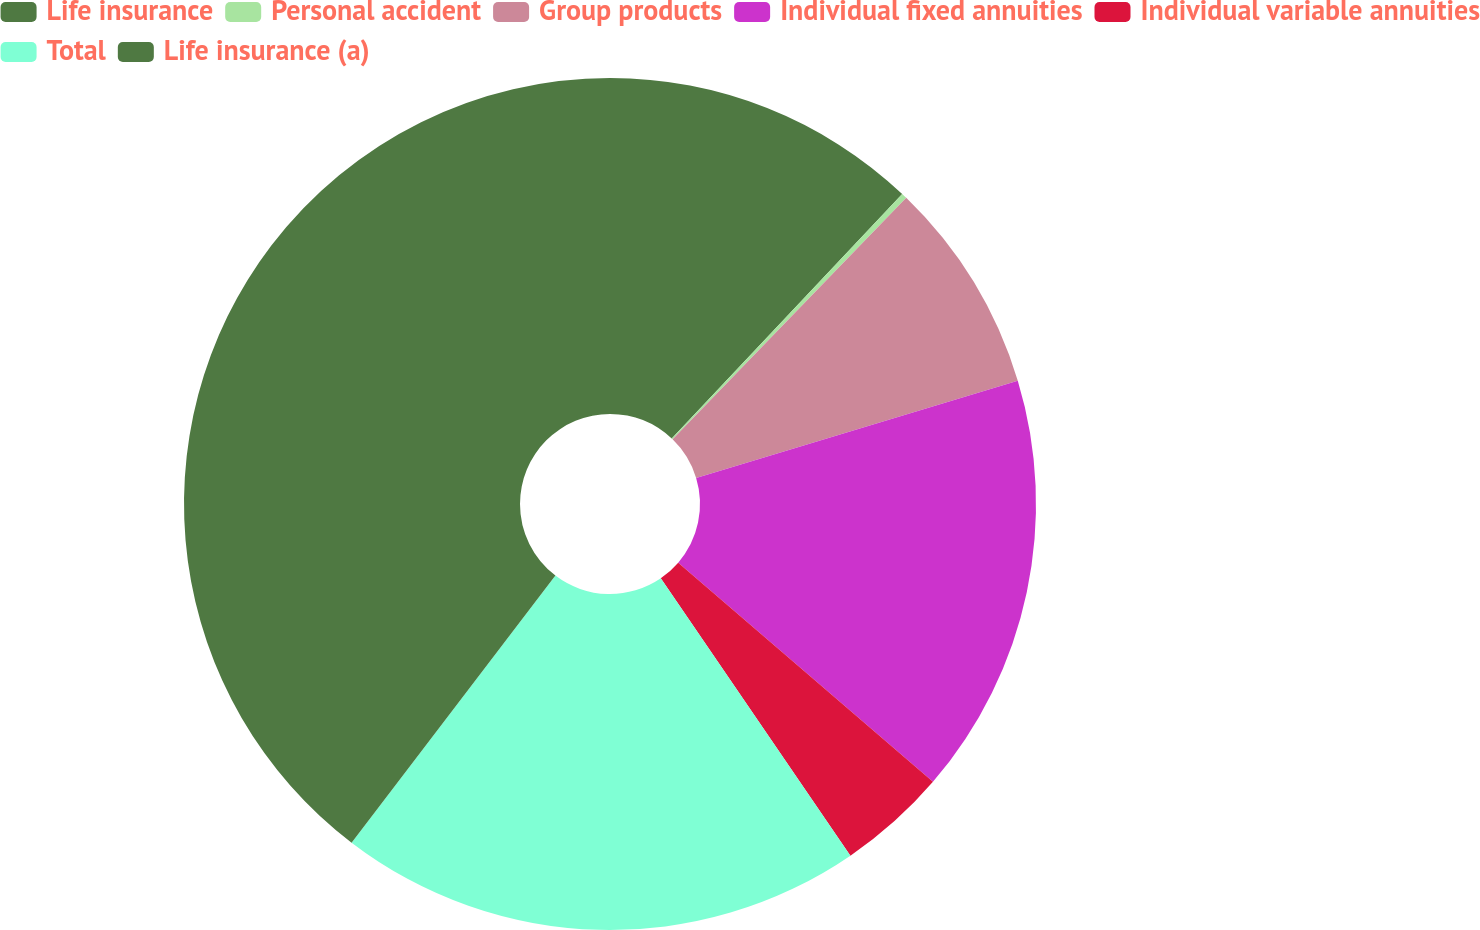Convert chart. <chart><loc_0><loc_0><loc_500><loc_500><pie_chart><fcel>Life insurance<fcel>Personal accident<fcel>Group products<fcel>Individual fixed annuities<fcel>Individual variable annuities<fcel>Total<fcel>Life insurance (a)<nl><fcel>12.03%<fcel>0.21%<fcel>8.09%<fcel>15.98%<fcel>4.15%<fcel>19.92%<fcel>39.63%<nl></chart> 